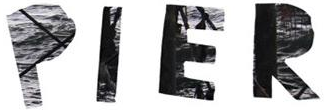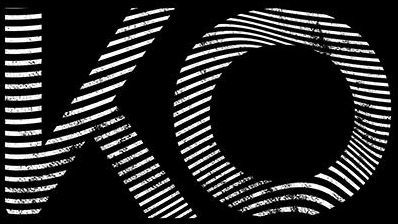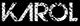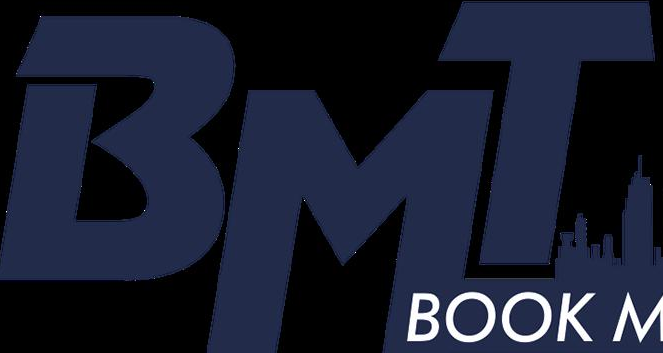What words are shown in these images in order, separated by a semicolon? PIER; KO; KΛROL; BMT 